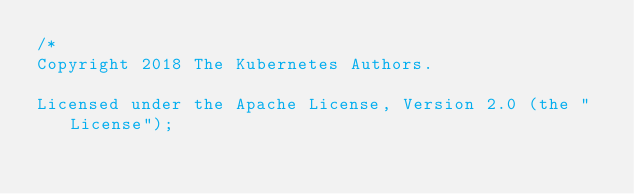<code> <loc_0><loc_0><loc_500><loc_500><_Go_>/*
Copyright 2018 The Kubernetes Authors.

Licensed under the Apache License, Version 2.0 (the "License");</code> 